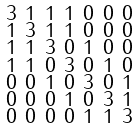<formula> <loc_0><loc_0><loc_500><loc_500>\begin{smallmatrix} 3 & 1 & 1 & 1 & 0 & 0 & 0 \\ 1 & 3 & 1 & 1 & 0 & 0 & 0 \\ 1 & 1 & 3 & 0 & 1 & 0 & 0 \\ 1 & 1 & 0 & 3 & 0 & 1 & 0 \\ 0 & 0 & 1 & 0 & 3 & 0 & 1 \\ 0 & 0 & 0 & 1 & 0 & 3 & 1 \\ 0 & 0 & 0 & 0 & 1 & 1 & 3 \end{smallmatrix}</formula> 